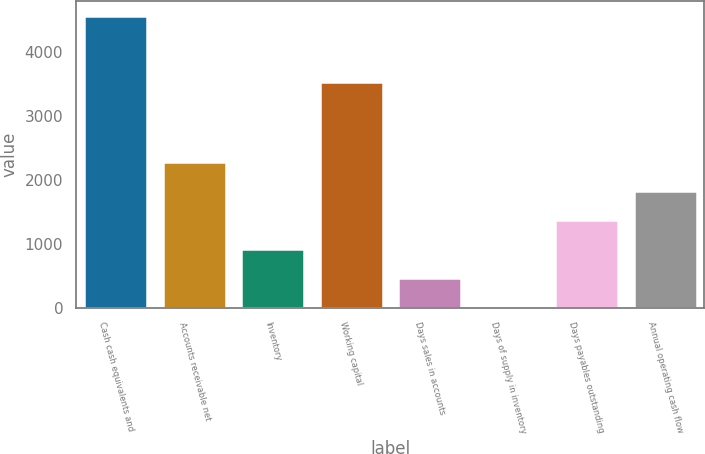Convert chart to OTSL. <chart><loc_0><loc_0><loc_500><loc_500><bar_chart><fcel>Cash cash equivalents and<fcel>Accounts receivable net<fcel>Inventory<fcel>Working capital<fcel>Days sales in accounts<fcel>Days of supply in inventory<fcel>Days payables outstanding<fcel>Annual operating cash flow<nl><fcel>4566<fcel>2285<fcel>916.4<fcel>3530<fcel>460.2<fcel>4<fcel>1372.6<fcel>1828.8<nl></chart> 